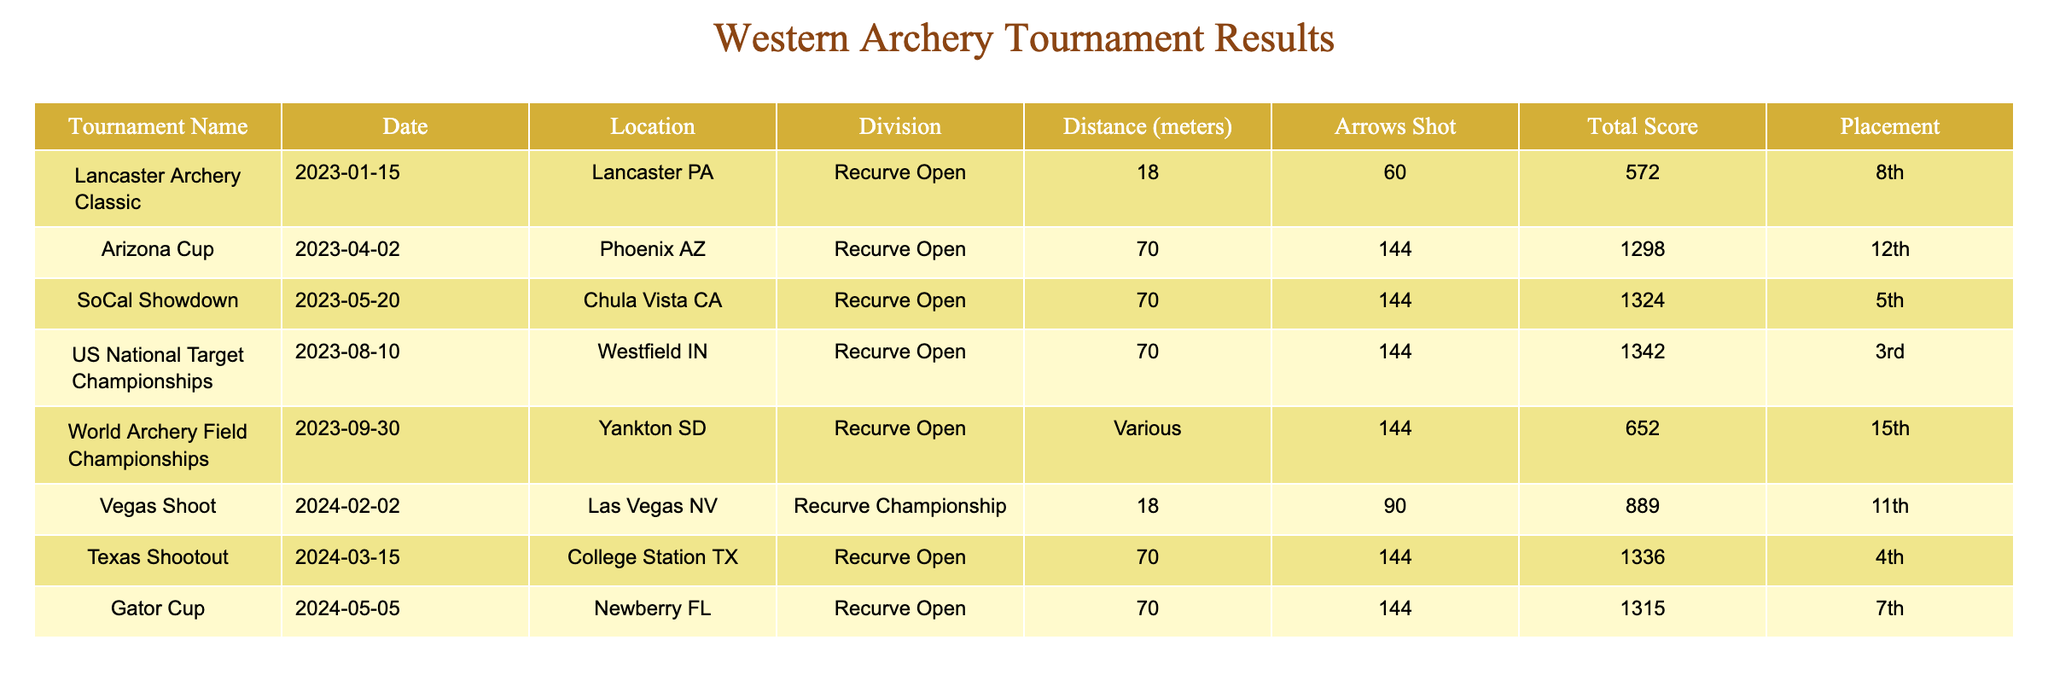What was the total score for the US National Target Championships? In the table, locate the row corresponding to the "US National Target Championships," where you find the column labeled "Total Score." The score recorded for this tournament is 1342.
Answer: 1342 Which tournament had the highest placement? To determine the highest placement, we look at the "Placement" column and find the lowest numerical value, which indicates the top-ranking position. The "US National Target Championships" has a placement of 3rd, which is the best position in the table.
Answer: US National Target Championships What is the average score of all tournaments? First, sum the "Total Score" values from all tournaments: 572 + 1298 + 1324 + 1342 + 652 + 889 + 1336 + 1315 = 9038. Then, divide this total by the number of tournaments (8) to calculate the average: 9038 / 8 = 1129.75.
Answer: 1129.75 Did the placement improve from the Lancaster Archery Classic to the Texas Shootout? For the Lancaster Archery Classic, the placement is 8th, and for the Texas Shootout, it is 4th. Since 4th is better (lower number) than 8th, we can conclude that the placement improved.
Answer: Yes How many arrows were shot at the World Archery Field Championships? Looking at the row for the "World Archery Field Championships," the "Arrows Shot" column indicates that 144 arrows were shot.
Answer: 144 What is the difference in total scores between the first and last tournaments listed? The first tournament listed is the "Lancaster Archery Classic" with a total score of 572, and the last tournament, "Gator Cup," has a score of 1315. To find the difference, subtract the first score from the last score: 1315 - 572 = 743.
Answer: 743 Which tournament had the longest shooting distance? In the table, check the "Distance (meters)" column. The longest distance listed is 70 meters, found in multiple tournaments. However, the "World Archery Field Championships" also states "Various," which implies different distances were used. For a specific length, "Arizona Cup," "SoCal Showdown," "US National Target Championships," "Texas Shootout," and "Gator Cup" all used 70 meters but indicate the same standard distance for comparison.
Answer: Multiple tournaments at 70 meters, "Various" for the World Archery Field Championships Was there a tournament with a score below 600? By scanning the "Total Score" column, the only score below 600 is from the "Lancaster Archery Classic," which scored 572. This confirms that there was indeed such a tournament.
Answer: Yes 